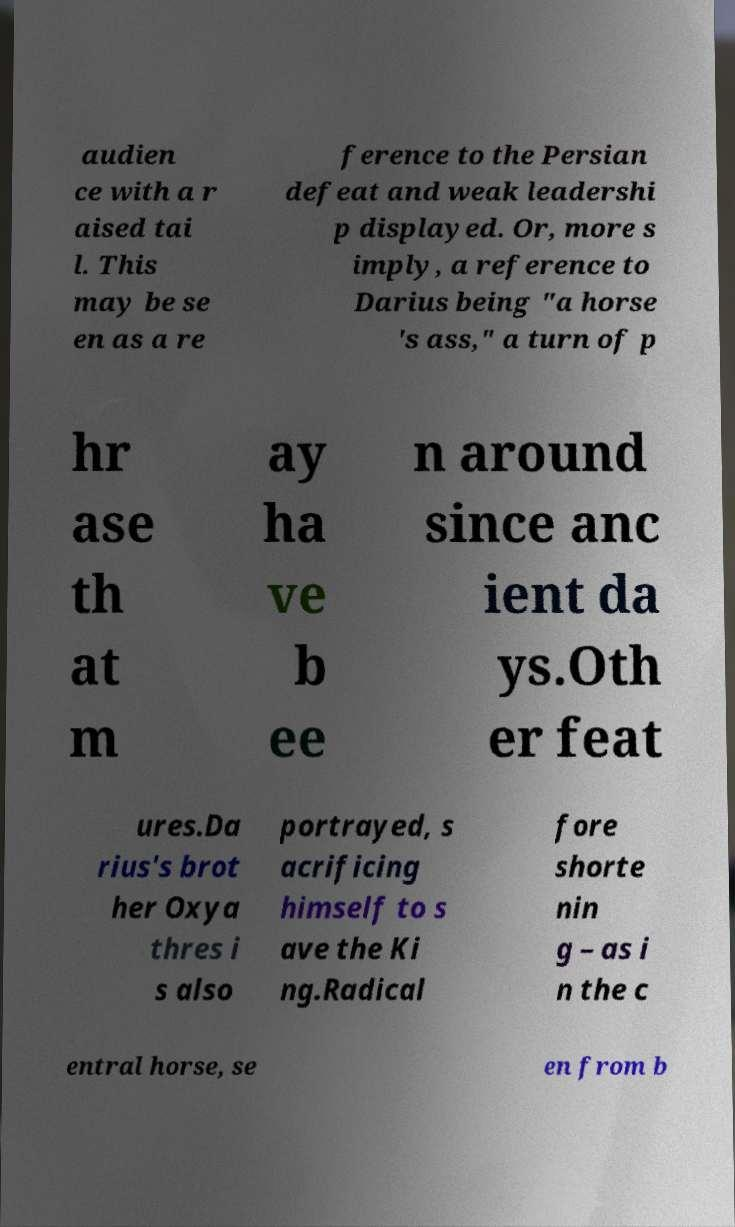Could you assist in decoding the text presented in this image and type it out clearly? audien ce with a r aised tai l. This may be se en as a re ference to the Persian defeat and weak leadershi p displayed. Or, more s imply, a reference to Darius being "a horse 's ass," a turn of p hr ase th at m ay ha ve b ee n around since anc ient da ys.Oth er feat ures.Da rius's brot her Oxya thres i s also portrayed, s acrificing himself to s ave the Ki ng.Radical fore shorte nin g – as i n the c entral horse, se en from b 